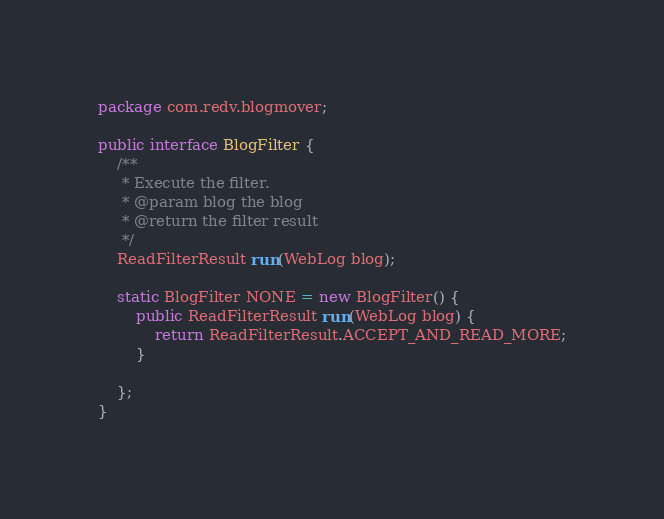<code> <loc_0><loc_0><loc_500><loc_500><_Java_>package com.redv.blogmover;

public interface BlogFilter {
	/**
	 * Execute the filter.
	 * @param blog the blog
	 * @return the filter result
	 */
	ReadFilterResult run(WebLog blog);

	static BlogFilter NONE = new BlogFilter() {
		public ReadFilterResult run(WebLog blog) {
			return ReadFilterResult.ACCEPT_AND_READ_MORE;
		}

	};
}
</code> 